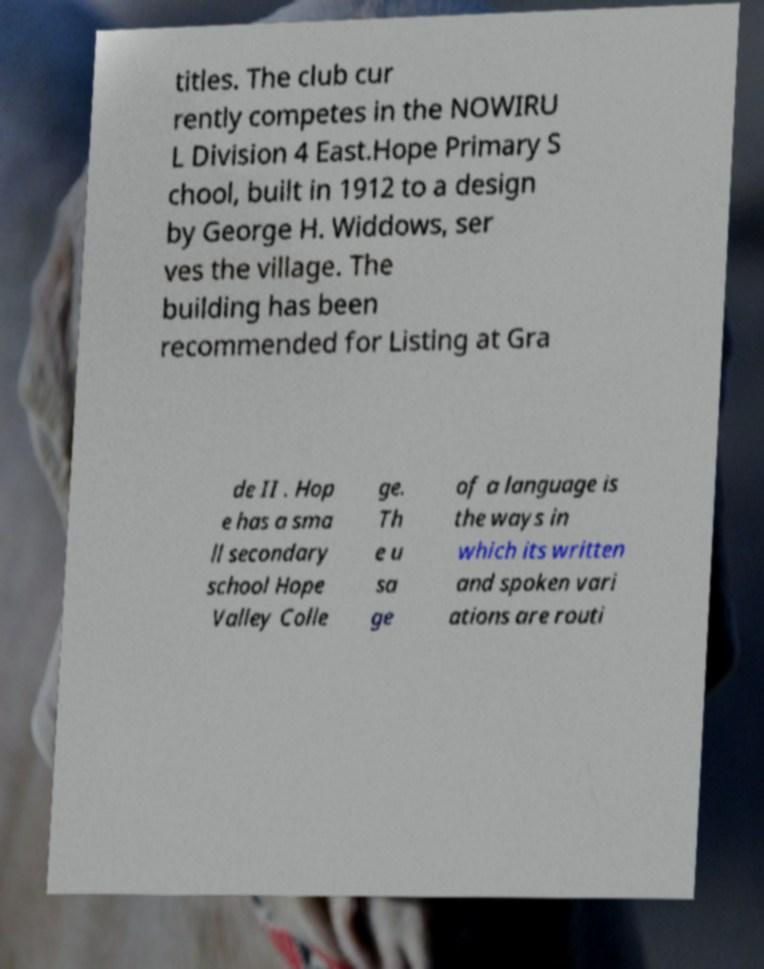Could you assist in decoding the text presented in this image and type it out clearly? titles. The club cur rently competes in the NOWIRU L Division 4 East.Hope Primary S chool, built in 1912 to a design by George H. Widdows, ser ves the village. The building has been recommended for Listing at Gra de II . Hop e has a sma ll secondary school Hope Valley Colle ge. Th e u sa ge of a language is the ways in which its written and spoken vari ations are routi 